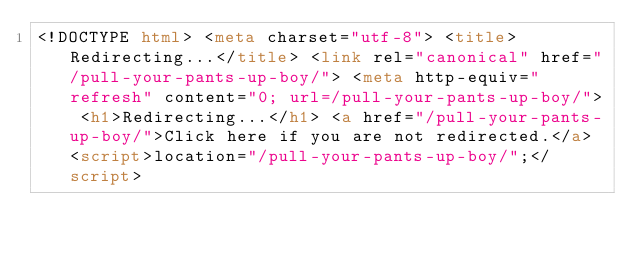<code> <loc_0><loc_0><loc_500><loc_500><_HTML_><!DOCTYPE html> <meta charset="utf-8"> <title>Redirecting...</title> <link rel="canonical" href="/pull-your-pants-up-boy/"> <meta http-equiv="refresh" content="0; url=/pull-your-pants-up-boy/"> <h1>Redirecting...</h1> <a href="/pull-your-pants-up-boy/">Click here if you are not redirected.</a> <script>location="/pull-your-pants-up-boy/";</script></code> 